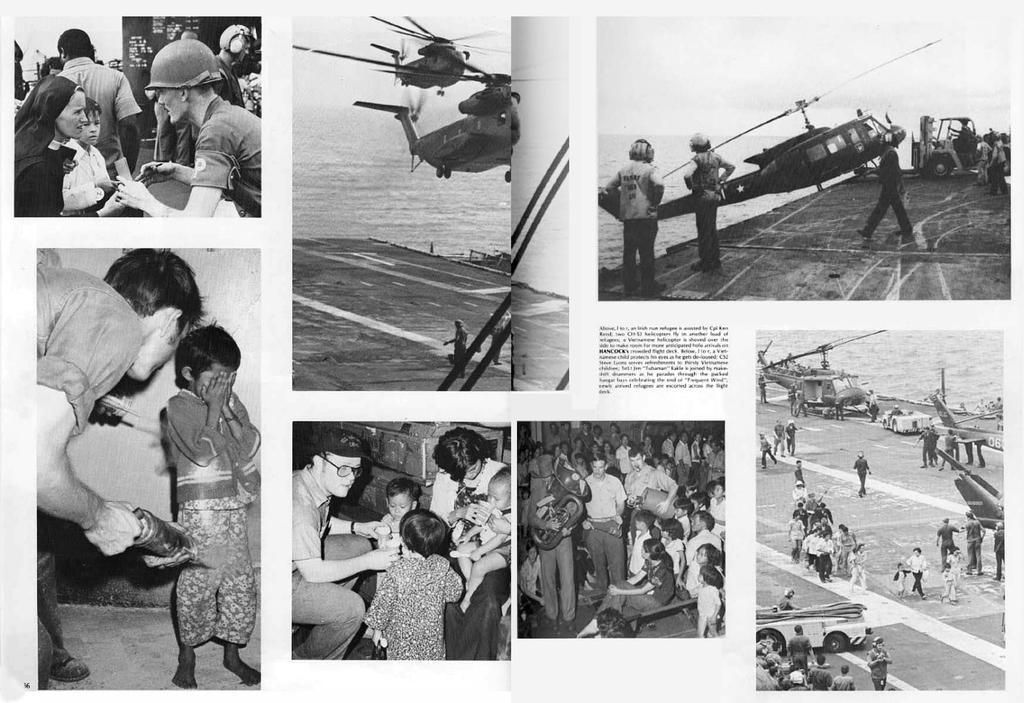Please provide a concise description of this image. This is an edited image with the collage of images. At the bottom we can see the group of persons holding some objects and standing and we can see the group of persons holding some objects and sitting. On the right we can see the group of choppers and a water body. In the center we can see the two choppers seems to be flying in the air and we can see the text on the image and the group of persons. 